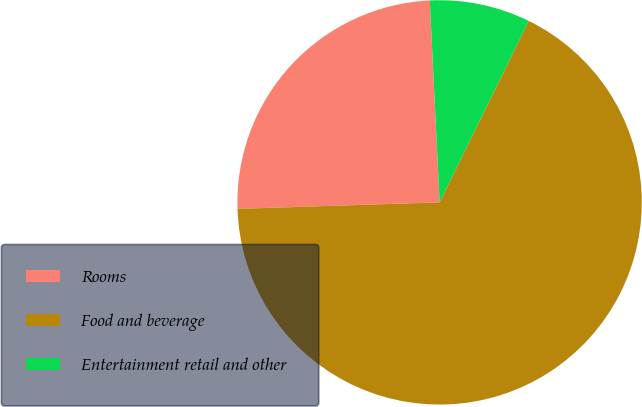Convert chart. <chart><loc_0><loc_0><loc_500><loc_500><pie_chart><fcel>Rooms<fcel>Food and beverage<fcel>Entertainment retail and other<nl><fcel>24.74%<fcel>67.22%<fcel>8.04%<nl></chart> 